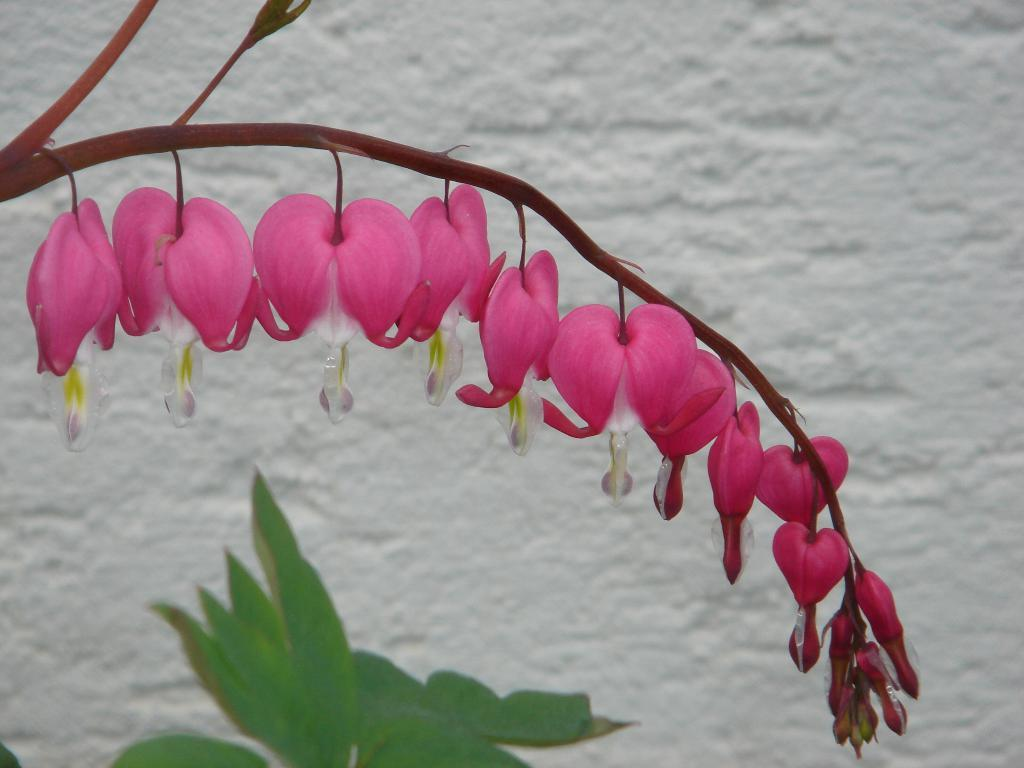What type of flowers can be seen on the plant in the image? There are pink flowers on a plant in the image. What color is the background of the image? The background of the image is white. What type of bag is hanging on the plant with the pink flowers? There is no bag present in the image; it only features pink flowers on a plant with a white background. 